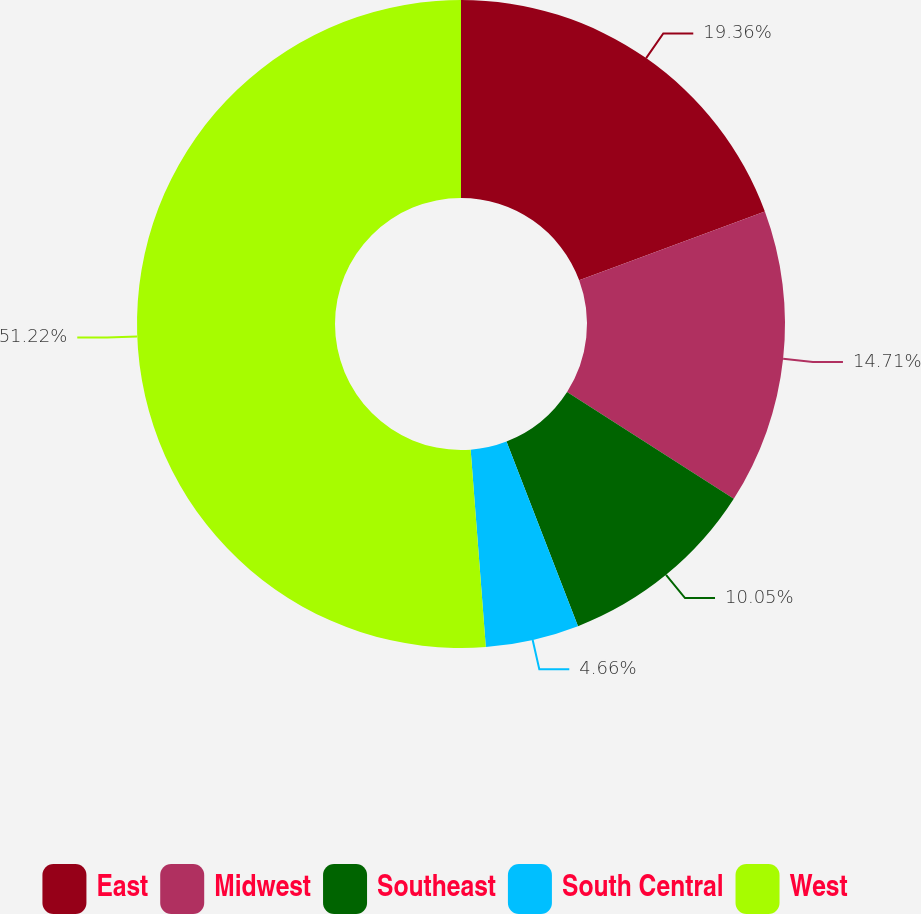Convert chart. <chart><loc_0><loc_0><loc_500><loc_500><pie_chart><fcel>East<fcel>Midwest<fcel>Southeast<fcel>South Central<fcel>West<nl><fcel>19.36%<fcel>14.71%<fcel>10.05%<fcel>4.66%<fcel>51.22%<nl></chart> 